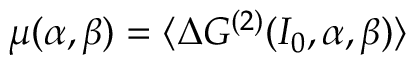Convert formula to latex. <formula><loc_0><loc_0><loc_500><loc_500>\mu ( \alpha , \beta ) = \langle \Delta G ^ { ( 2 ) } ( I _ { 0 } , \alpha , \beta ) \rangle</formula> 